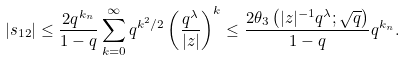Convert formula to latex. <formula><loc_0><loc_0><loc_500><loc_500>| s _ { 1 2 } | & \leq \frac { 2 q ^ { k _ { n } } } { 1 - q } \sum _ { k = 0 } ^ { \infty } q ^ { k ^ { 2 } / 2 } \left ( \frac { q ^ { \lambda } } { | z | } \right ) ^ { k } \leq \frac { 2 \theta _ { 3 } \left ( | z | ^ { - 1 } q ^ { \lambda } ; \sqrt { q } \right ) } { 1 - q } q ^ { k _ { n } } .</formula> 